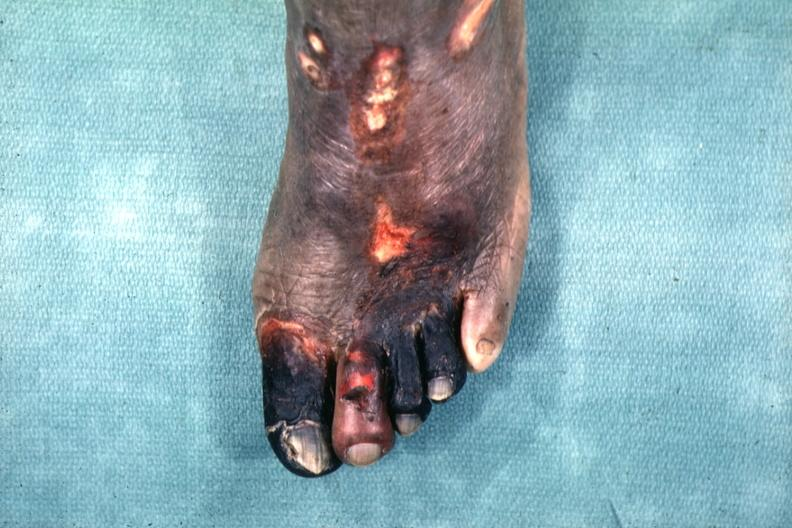what does this image show?
Answer the question using a single word or phrase. Excellent example of gangrene of the first four toes 